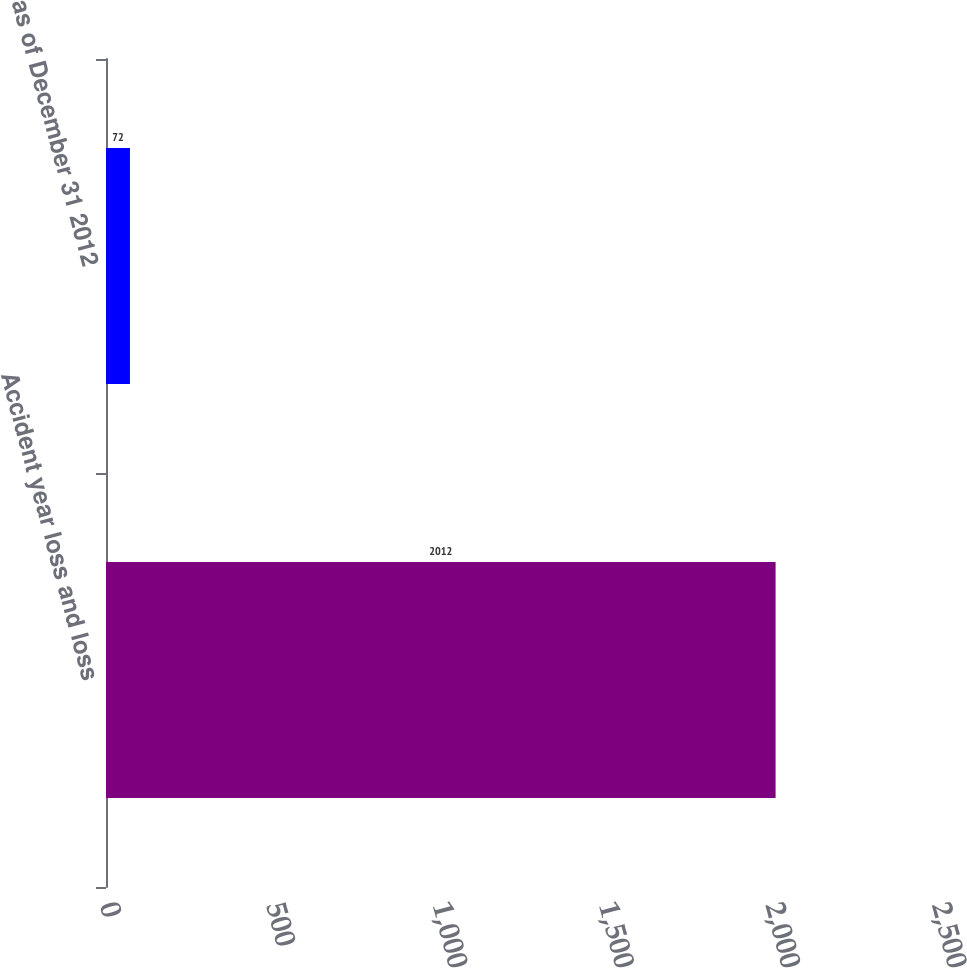Convert chart to OTSL. <chart><loc_0><loc_0><loc_500><loc_500><bar_chart><fcel>Accident year loss and loss<fcel>as of December 31 2012<nl><fcel>2012<fcel>72<nl></chart> 